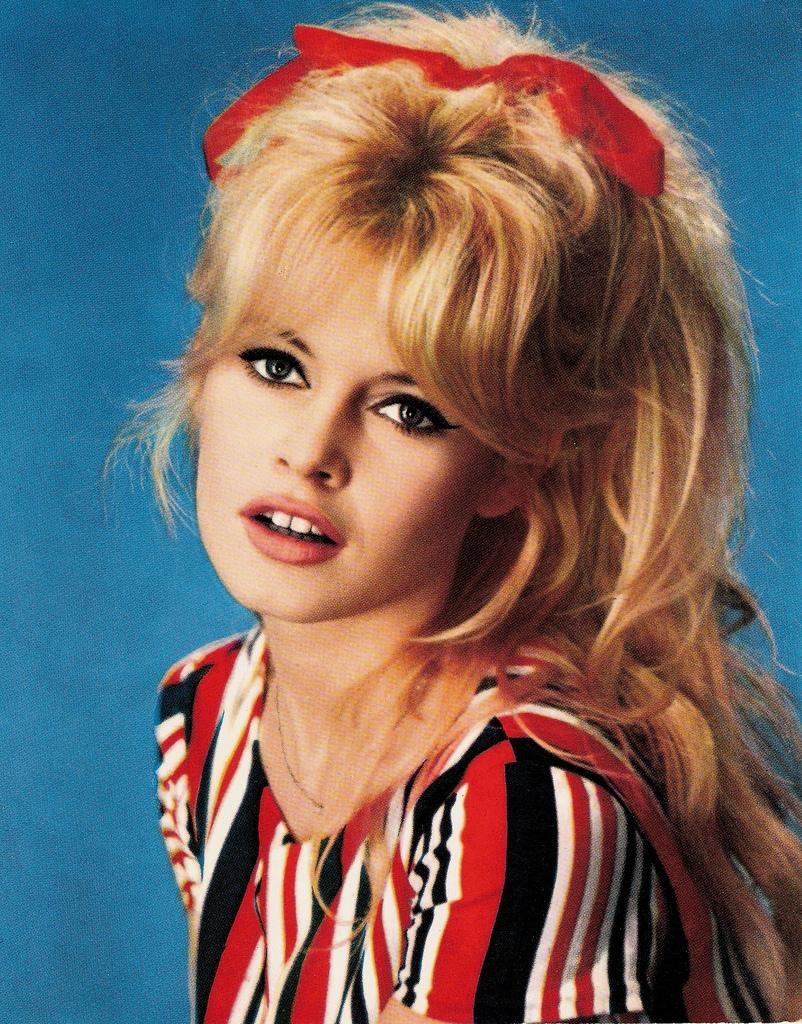Who is present in the image? There is a woman in the image. What is the woman wearing? The woman is wearing a red shirt. What can be seen in the background of the image? There is a blue surface in the background of the image. What type of songs can be heard coming from the woman's stomach in the image? There is no indication in the image that the woman's stomach is making any sounds, so it's not possible to determine what, if any, songs might be heard. 